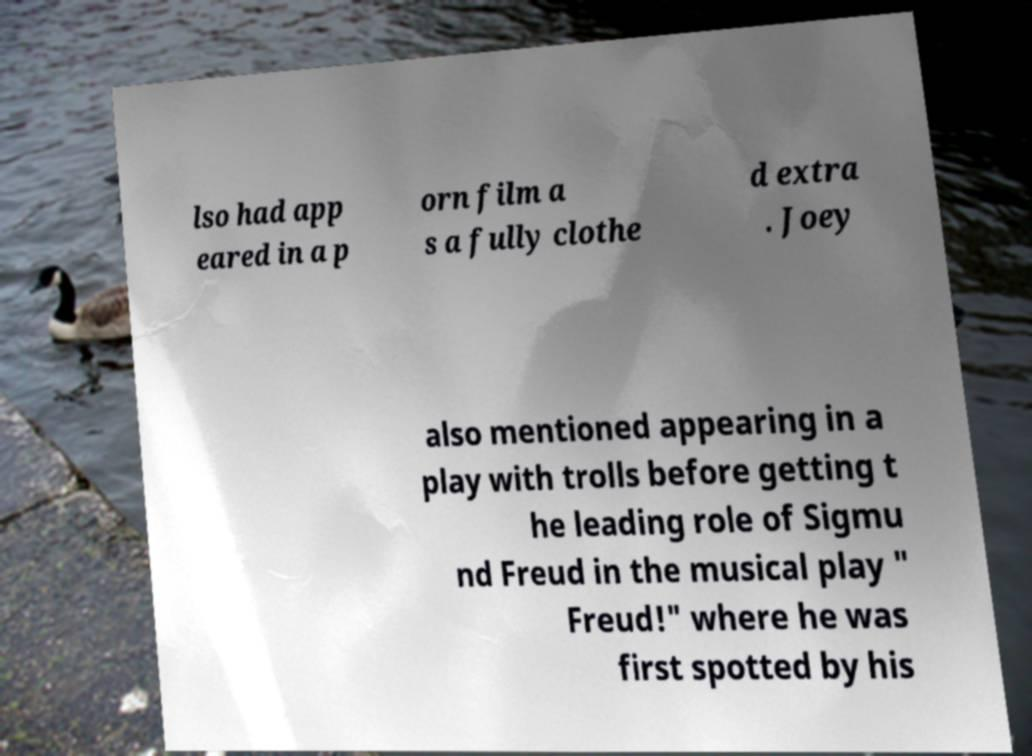For documentation purposes, I need the text within this image transcribed. Could you provide that? lso had app eared in a p orn film a s a fully clothe d extra . Joey also mentioned appearing in a play with trolls before getting t he leading role of Sigmu nd Freud in the musical play " Freud!" where he was first spotted by his 